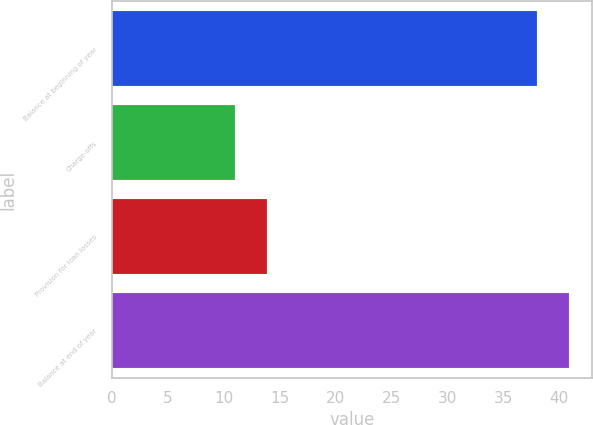Convert chart. <chart><loc_0><loc_0><loc_500><loc_500><bar_chart><fcel>Balance at beginning of year<fcel>Charge-offs<fcel>Provision for loan losses<fcel>Balance at end of year<nl><fcel>38<fcel>11<fcel>13.9<fcel>40.9<nl></chart> 